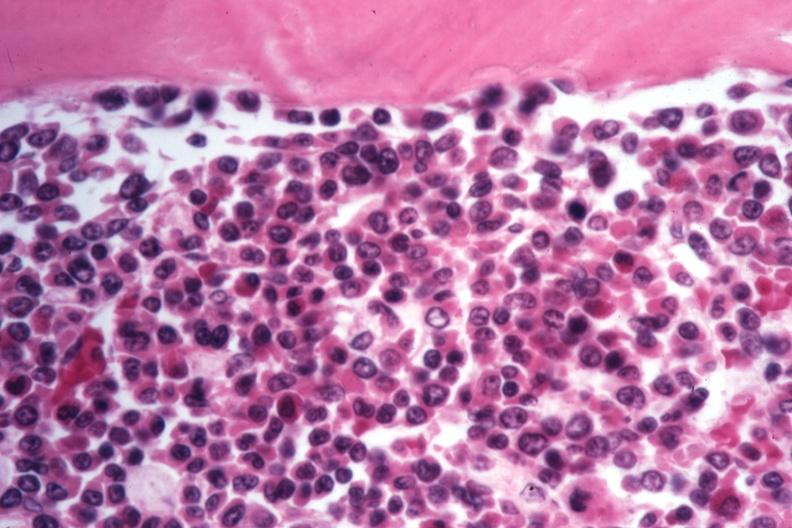s adrenal of premature 30 week gestation gram infant lesion present?
Answer the question using a single word or phrase. No 